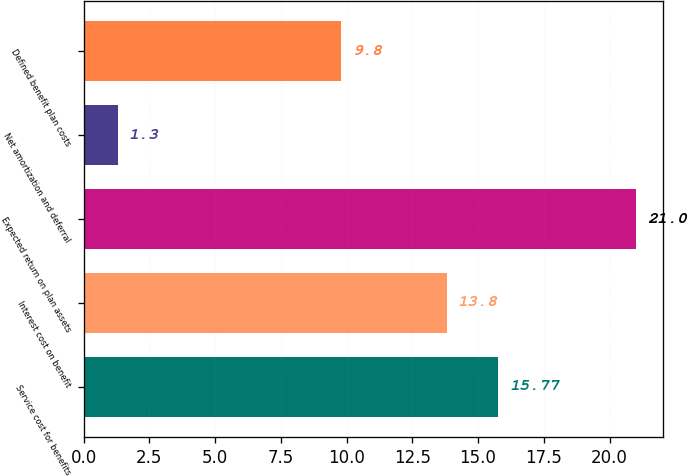Convert chart to OTSL. <chart><loc_0><loc_0><loc_500><loc_500><bar_chart><fcel>Service cost for benefits<fcel>Interest cost on benefit<fcel>Expected return on plan assets<fcel>Net amortization and deferral<fcel>Defined benefit plan costs<nl><fcel>15.77<fcel>13.8<fcel>21<fcel>1.3<fcel>9.8<nl></chart> 